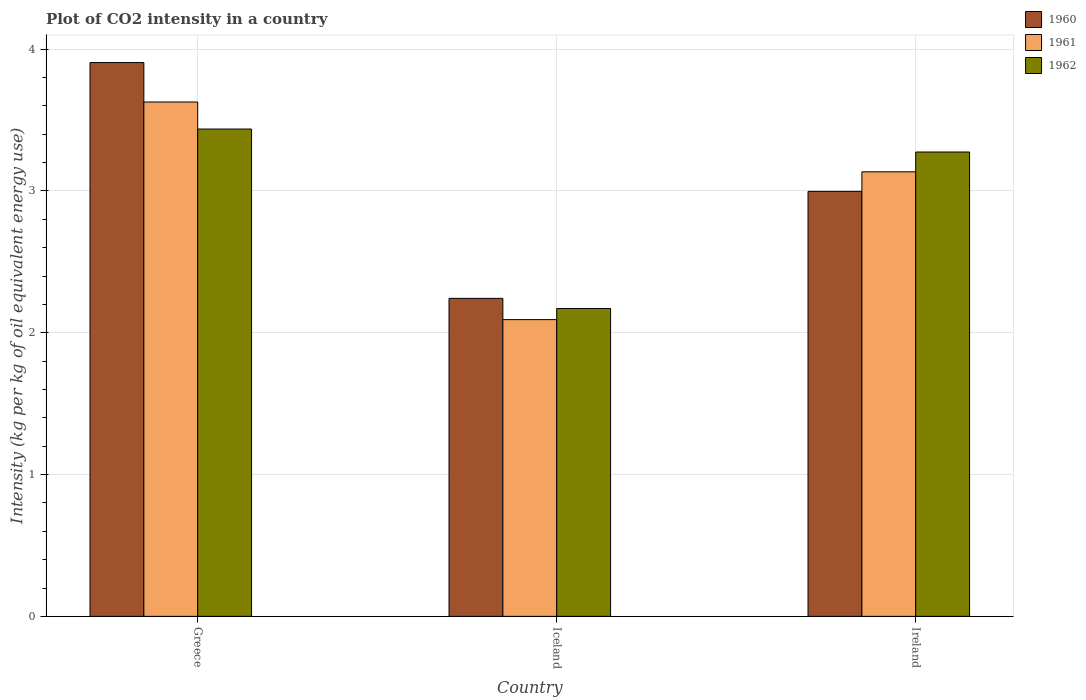How many groups of bars are there?
Your answer should be very brief. 3. Are the number of bars per tick equal to the number of legend labels?
Provide a succinct answer. Yes. How many bars are there on the 2nd tick from the left?
Provide a short and direct response. 3. How many bars are there on the 3rd tick from the right?
Make the answer very short. 3. What is the label of the 1st group of bars from the left?
Keep it short and to the point. Greece. What is the CO2 intensity in in 1961 in Ireland?
Your answer should be very brief. 3.14. Across all countries, what is the maximum CO2 intensity in in 1960?
Keep it short and to the point. 3.91. Across all countries, what is the minimum CO2 intensity in in 1960?
Provide a succinct answer. 2.24. What is the total CO2 intensity in in 1961 in the graph?
Provide a short and direct response. 8.86. What is the difference between the CO2 intensity in in 1962 in Greece and that in Iceland?
Your answer should be compact. 1.27. What is the difference between the CO2 intensity in in 1960 in Ireland and the CO2 intensity in in 1961 in Greece?
Ensure brevity in your answer.  -0.63. What is the average CO2 intensity in in 1961 per country?
Offer a very short reply. 2.95. What is the difference between the CO2 intensity in of/in 1960 and CO2 intensity in of/in 1962 in Greece?
Your answer should be compact. 0.47. What is the ratio of the CO2 intensity in in 1960 in Greece to that in Ireland?
Your answer should be very brief. 1.3. Is the CO2 intensity in in 1960 in Iceland less than that in Ireland?
Your response must be concise. Yes. What is the difference between the highest and the second highest CO2 intensity in in 1960?
Make the answer very short. -0.91. What is the difference between the highest and the lowest CO2 intensity in in 1961?
Offer a terse response. 1.53. In how many countries, is the CO2 intensity in in 1962 greater than the average CO2 intensity in in 1962 taken over all countries?
Your answer should be very brief. 2. Is it the case that in every country, the sum of the CO2 intensity in in 1962 and CO2 intensity in in 1960 is greater than the CO2 intensity in in 1961?
Keep it short and to the point. Yes. Are all the bars in the graph horizontal?
Provide a succinct answer. No. Does the graph contain any zero values?
Keep it short and to the point. No. Does the graph contain grids?
Offer a very short reply. Yes. Where does the legend appear in the graph?
Your response must be concise. Top right. How many legend labels are there?
Your answer should be compact. 3. What is the title of the graph?
Offer a very short reply. Plot of CO2 intensity in a country. What is the label or title of the X-axis?
Provide a succinct answer. Country. What is the label or title of the Y-axis?
Keep it short and to the point. Intensity (kg per kg of oil equivalent energy use). What is the Intensity (kg per kg of oil equivalent energy use) of 1960 in Greece?
Your answer should be compact. 3.91. What is the Intensity (kg per kg of oil equivalent energy use) of 1961 in Greece?
Your response must be concise. 3.63. What is the Intensity (kg per kg of oil equivalent energy use) in 1962 in Greece?
Your answer should be compact. 3.44. What is the Intensity (kg per kg of oil equivalent energy use) of 1960 in Iceland?
Ensure brevity in your answer.  2.24. What is the Intensity (kg per kg of oil equivalent energy use) of 1961 in Iceland?
Your answer should be compact. 2.09. What is the Intensity (kg per kg of oil equivalent energy use) of 1962 in Iceland?
Your response must be concise. 2.17. What is the Intensity (kg per kg of oil equivalent energy use) in 1960 in Ireland?
Your response must be concise. 3. What is the Intensity (kg per kg of oil equivalent energy use) in 1961 in Ireland?
Your answer should be compact. 3.14. What is the Intensity (kg per kg of oil equivalent energy use) in 1962 in Ireland?
Your answer should be very brief. 3.27. Across all countries, what is the maximum Intensity (kg per kg of oil equivalent energy use) in 1960?
Ensure brevity in your answer.  3.91. Across all countries, what is the maximum Intensity (kg per kg of oil equivalent energy use) of 1961?
Your response must be concise. 3.63. Across all countries, what is the maximum Intensity (kg per kg of oil equivalent energy use) in 1962?
Your answer should be very brief. 3.44. Across all countries, what is the minimum Intensity (kg per kg of oil equivalent energy use) of 1960?
Provide a short and direct response. 2.24. Across all countries, what is the minimum Intensity (kg per kg of oil equivalent energy use) of 1961?
Ensure brevity in your answer.  2.09. Across all countries, what is the minimum Intensity (kg per kg of oil equivalent energy use) of 1962?
Keep it short and to the point. 2.17. What is the total Intensity (kg per kg of oil equivalent energy use) in 1960 in the graph?
Your response must be concise. 9.15. What is the total Intensity (kg per kg of oil equivalent energy use) of 1961 in the graph?
Give a very brief answer. 8.86. What is the total Intensity (kg per kg of oil equivalent energy use) in 1962 in the graph?
Offer a terse response. 8.88. What is the difference between the Intensity (kg per kg of oil equivalent energy use) of 1960 in Greece and that in Iceland?
Your answer should be very brief. 1.66. What is the difference between the Intensity (kg per kg of oil equivalent energy use) in 1961 in Greece and that in Iceland?
Keep it short and to the point. 1.53. What is the difference between the Intensity (kg per kg of oil equivalent energy use) in 1962 in Greece and that in Iceland?
Offer a terse response. 1.27. What is the difference between the Intensity (kg per kg of oil equivalent energy use) in 1960 in Greece and that in Ireland?
Keep it short and to the point. 0.91. What is the difference between the Intensity (kg per kg of oil equivalent energy use) of 1961 in Greece and that in Ireland?
Offer a terse response. 0.49. What is the difference between the Intensity (kg per kg of oil equivalent energy use) in 1962 in Greece and that in Ireland?
Provide a short and direct response. 0.16. What is the difference between the Intensity (kg per kg of oil equivalent energy use) of 1960 in Iceland and that in Ireland?
Your answer should be compact. -0.75. What is the difference between the Intensity (kg per kg of oil equivalent energy use) in 1961 in Iceland and that in Ireland?
Provide a succinct answer. -1.04. What is the difference between the Intensity (kg per kg of oil equivalent energy use) of 1962 in Iceland and that in Ireland?
Offer a terse response. -1.1. What is the difference between the Intensity (kg per kg of oil equivalent energy use) of 1960 in Greece and the Intensity (kg per kg of oil equivalent energy use) of 1961 in Iceland?
Make the answer very short. 1.81. What is the difference between the Intensity (kg per kg of oil equivalent energy use) in 1960 in Greece and the Intensity (kg per kg of oil equivalent energy use) in 1962 in Iceland?
Offer a terse response. 1.73. What is the difference between the Intensity (kg per kg of oil equivalent energy use) in 1961 in Greece and the Intensity (kg per kg of oil equivalent energy use) in 1962 in Iceland?
Your answer should be compact. 1.46. What is the difference between the Intensity (kg per kg of oil equivalent energy use) in 1960 in Greece and the Intensity (kg per kg of oil equivalent energy use) in 1961 in Ireland?
Make the answer very short. 0.77. What is the difference between the Intensity (kg per kg of oil equivalent energy use) of 1960 in Greece and the Intensity (kg per kg of oil equivalent energy use) of 1962 in Ireland?
Make the answer very short. 0.63. What is the difference between the Intensity (kg per kg of oil equivalent energy use) in 1961 in Greece and the Intensity (kg per kg of oil equivalent energy use) in 1962 in Ireland?
Provide a succinct answer. 0.35. What is the difference between the Intensity (kg per kg of oil equivalent energy use) in 1960 in Iceland and the Intensity (kg per kg of oil equivalent energy use) in 1961 in Ireland?
Provide a short and direct response. -0.89. What is the difference between the Intensity (kg per kg of oil equivalent energy use) of 1960 in Iceland and the Intensity (kg per kg of oil equivalent energy use) of 1962 in Ireland?
Offer a very short reply. -1.03. What is the difference between the Intensity (kg per kg of oil equivalent energy use) in 1961 in Iceland and the Intensity (kg per kg of oil equivalent energy use) in 1962 in Ireland?
Your answer should be compact. -1.18. What is the average Intensity (kg per kg of oil equivalent energy use) in 1960 per country?
Give a very brief answer. 3.05. What is the average Intensity (kg per kg of oil equivalent energy use) of 1961 per country?
Ensure brevity in your answer.  2.95. What is the average Intensity (kg per kg of oil equivalent energy use) in 1962 per country?
Keep it short and to the point. 2.96. What is the difference between the Intensity (kg per kg of oil equivalent energy use) in 1960 and Intensity (kg per kg of oil equivalent energy use) in 1961 in Greece?
Keep it short and to the point. 0.28. What is the difference between the Intensity (kg per kg of oil equivalent energy use) of 1960 and Intensity (kg per kg of oil equivalent energy use) of 1962 in Greece?
Keep it short and to the point. 0.47. What is the difference between the Intensity (kg per kg of oil equivalent energy use) of 1961 and Intensity (kg per kg of oil equivalent energy use) of 1962 in Greece?
Offer a very short reply. 0.19. What is the difference between the Intensity (kg per kg of oil equivalent energy use) of 1960 and Intensity (kg per kg of oil equivalent energy use) of 1961 in Iceland?
Ensure brevity in your answer.  0.15. What is the difference between the Intensity (kg per kg of oil equivalent energy use) in 1960 and Intensity (kg per kg of oil equivalent energy use) in 1962 in Iceland?
Your response must be concise. 0.07. What is the difference between the Intensity (kg per kg of oil equivalent energy use) of 1961 and Intensity (kg per kg of oil equivalent energy use) of 1962 in Iceland?
Provide a short and direct response. -0.08. What is the difference between the Intensity (kg per kg of oil equivalent energy use) of 1960 and Intensity (kg per kg of oil equivalent energy use) of 1961 in Ireland?
Provide a short and direct response. -0.14. What is the difference between the Intensity (kg per kg of oil equivalent energy use) of 1960 and Intensity (kg per kg of oil equivalent energy use) of 1962 in Ireland?
Your answer should be very brief. -0.28. What is the difference between the Intensity (kg per kg of oil equivalent energy use) in 1961 and Intensity (kg per kg of oil equivalent energy use) in 1962 in Ireland?
Your answer should be very brief. -0.14. What is the ratio of the Intensity (kg per kg of oil equivalent energy use) of 1960 in Greece to that in Iceland?
Give a very brief answer. 1.74. What is the ratio of the Intensity (kg per kg of oil equivalent energy use) in 1961 in Greece to that in Iceland?
Offer a terse response. 1.73. What is the ratio of the Intensity (kg per kg of oil equivalent energy use) in 1962 in Greece to that in Iceland?
Your response must be concise. 1.58. What is the ratio of the Intensity (kg per kg of oil equivalent energy use) of 1960 in Greece to that in Ireland?
Make the answer very short. 1.3. What is the ratio of the Intensity (kg per kg of oil equivalent energy use) of 1961 in Greece to that in Ireland?
Give a very brief answer. 1.16. What is the ratio of the Intensity (kg per kg of oil equivalent energy use) of 1962 in Greece to that in Ireland?
Give a very brief answer. 1.05. What is the ratio of the Intensity (kg per kg of oil equivalent energy use) of 1960 in Iceland to that in Ireland?
Make the answer very short. 0.75. What is the ratio of the Intensity (kg per kg of oil equivalent energy use) in 1961 in Iceland to that in Ireland?
Offer a very short reply. 0.67. What is the ratio of the Intensity (kg per kg of oil equivalent energy use) in 1962 in Iceland to that in Ireland?
Your answer should be compact. 0.66. What is the difference between the highest and the second highest Intensity (kg per kg of oil equivalent energy use) of 1960?
Give a very brief answer. 0.91. What is the difference between the highest and the second highest Intensity (kg per kg of oil equivalent energy use) in 1961?
Make the answer very short. 0.49. What is the difference between the highest and the second highest Intensity (kg per kg of oil equivalent energy use) in 1962?
Your answer should be compact. 0.16. What is the difference between the highest and the lowest Intensity (kg per kg of oil equivalent energy use) in 1960?
Provide a short and direct response. 1.66. What is the difference between the highest and the lowest Intensity (kg per kg of oil equivalent energy use) of 1961?
Your answer should be compact. 1.53. What is the difference between the highest and the lowest Intensity (kg per kg of oil equivalent energy use) in 1962?
Provide a succinct answer. 1.27. 